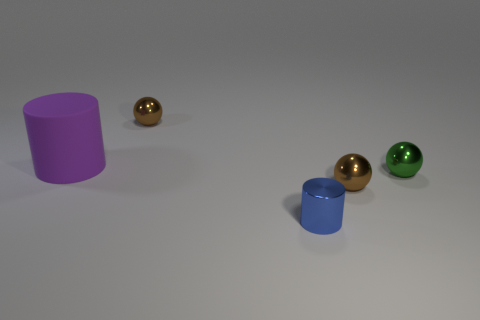What number of other things are there of the same material as the small blue cylinder? There are three objects that share the same glossy, solid material characteristic as the small blue cylinder in the image - these include a golden sphere, another golden sphere of a different size, and a green sphere. 